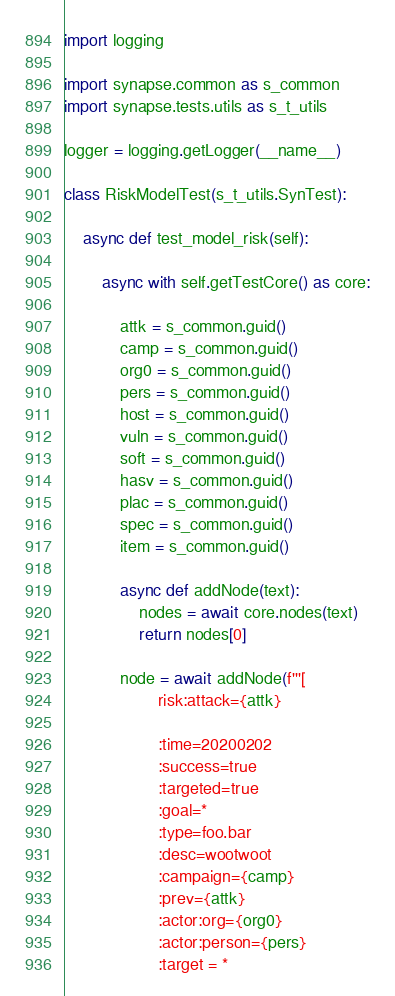Convert code to text. <code><loc_0><loc_0><loc_500><loc_500><_Python_>import logging

import synapse.common as s_common
import synapse.tests.utils as s_t_utils

logger = logging.getLogger(__name__)

class RiskModelTest(s_t_utils.SynTest):

    async def test_model_risk(self):

        async with self.getTestCore() as core:

            attk = s_common.guid()
            camp = s_common.guid()
            org0 = s_common.guid()
            pers = s_common.guid()
            host = s_common.guid()
            vuln = s_common.guid()
            soft = s_common.guid()
            hasv = s_common.guid()
            plac = s_common.guid()
            spec = s_common.guid()
            item = s_common.guid()

            async def addNode(text):
                nodes = await core.nodes(text)
                return nodes[0]

            node = await addNode(f'''[
                    risk:attack={attk}

                    :time=20200202
                    :success=true
                    :targeted=true
                    :goal=*
                    :type=foo.bar
                    :desc=wootwoot
                    :campaign={camp}
                    :prev={attk}
                    :actor:org={org0}
                    :actor:person={pers}
                    :target = *</code> 